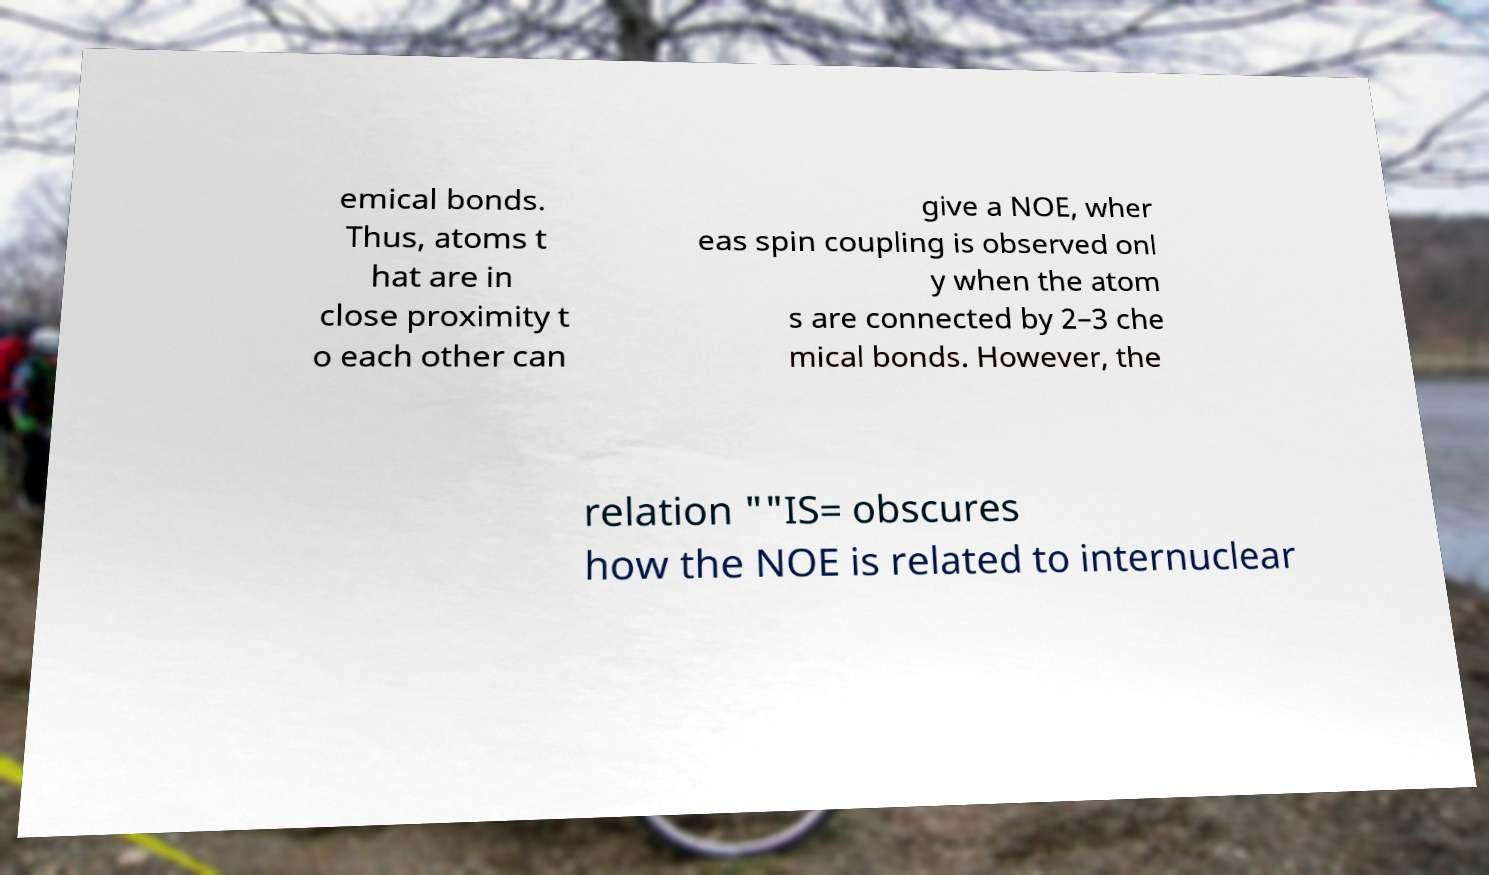There's text embedded in this image that I need extracted. Can you transcribe it verbatim? emical bonds. Thus, atoms t hat are in close proximity t o each other can give a NOE, wher eas spin coupling is observed onl y when the atom s are connected by 2–3 che mical bonds. However, the relation ""IS= obscures how the NOE is related to internuclear 